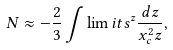Convert formula to latex. <formula><loc_0><loc_0><loc_500><loc_500>N \approx - \frac { 2 } { 3 } \int \lim i t s ^ { z } \frac { d { z } } { x _ { c } ^ { 2 } z } ,</formula> 